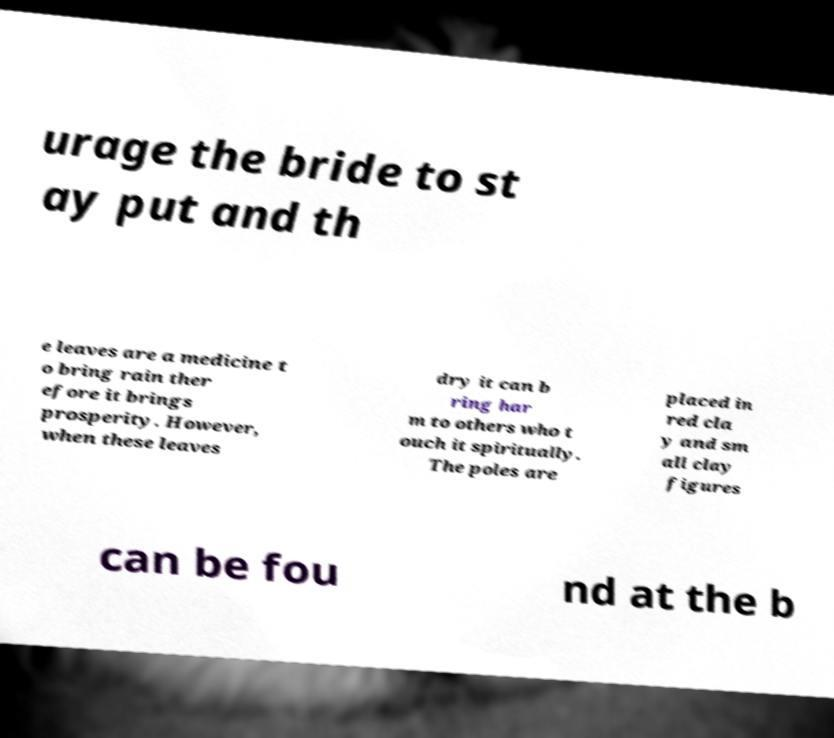Could you assist in decoding the text presented in this image and type it out clearly? urage the bride to st ay put and th e leaves are a medicine t o bring rain ther efore it brings prosperity. However, when these leaves dry it can b ring har m to others who t ouch it spiritually. The poles are placed in red cla y and sm all clay figures can be fou nd at the b 